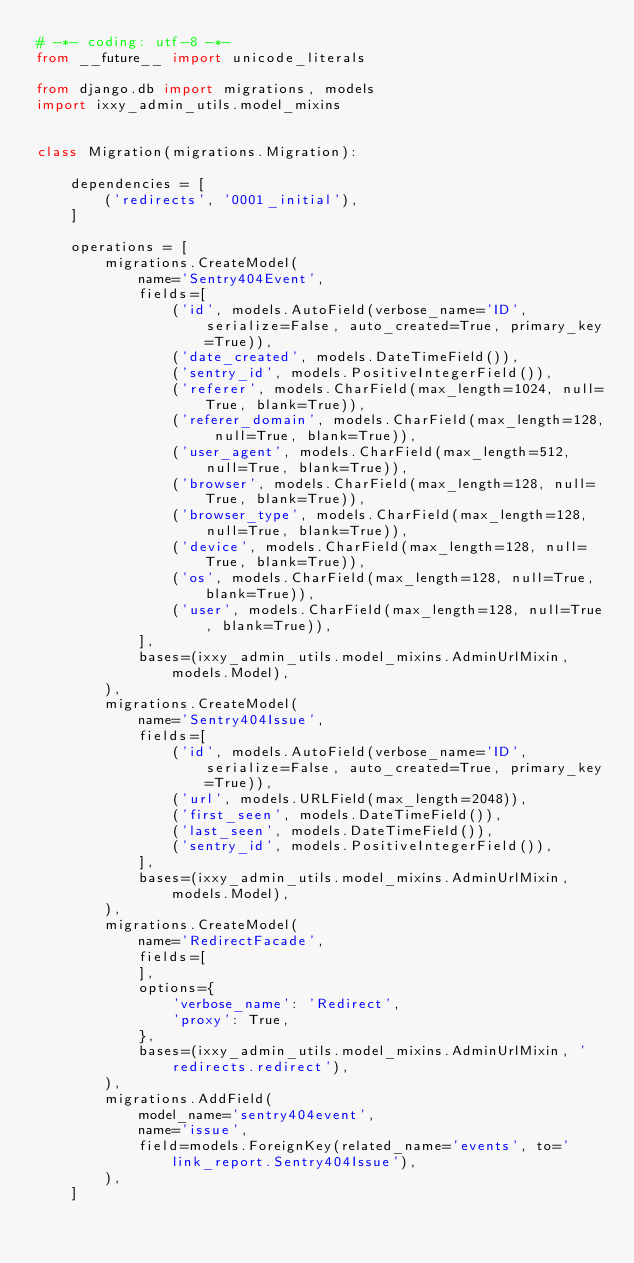<code> <loc_0><loc_0><loc_500><loc_500><_Python_># -*- coding: utf-8 -*-
from __future__ import unicode_literals

from django.db import migrations, models
import ixxy_admin_utils.model_mixins


class Migration(migrations.Migration):

    dependencies = [
        ('redirects', '0001_initial'),
    ]

    operations = [
        migrations.CreateModel(
            name='Sentry404Event',
            fields=[
                ('id', models.AutoField(verbose_name='ID', serialize=False, auto_created=True, primary_key=True)),
                ('date_created', models.DateTimeField()),
                ('sentry_id', models.PositiveIntegerField()),
                ('referer', models.CharField(max_length=1024, null=True, blank=True)),
                ('referer_domain', models.CharField(max_length=128, null=True, blank=True)),
                ('user_agent', models.CharField(max_length=512, null=True, blank=True)),
                ('browser', models.CharField(max_length=128, null=True, blank=True)),
                ('browser_type', models.CharField(max_length=128, null=True, blank=True)),
                ('device', models.CharField(max_length=128, null=True, blank=True)),
                ('os', models.CharField(max_length=128, null=True, blank=True)),
                ('user', models.CharField(max_length=128, null=True, blank=True)),
            ],
            bases=(ixxy_admin_utils.model_mixins.AdminUrlMixin, models.Model),
        ),
        migrations.CreateModel(
            name='Sentry404Issue',
            fields=[
                ('id', models.AutoField(verbose_name='ID', serialize=False, auto_created=True, primary_key=True)),
                ('url', models.URLField(max_length=2048)),
                ('first_seen', models.DateTimeField()),
                ('last_seen', models.DateTimeField()),
                ('sentry_id', models.PositiveIntegerField()),
            ],
            bases=(ixxy_admin_utils.model_mixins.AdminUrlMixin, models.Model),
        ),
        migrations.CreateModel(
            name='RedirectFacade',
            fields=[
            ],
            options={
                'verbose_name': 'Redirect',
                'proxy': True,
            },
            bases=(ixxy_admin_utils.model_mixins.AdminUrlMixin, 'redirects.redirect'),
        ),
        migrations.AddField(
            model_name='sentry404event',
            name='issue',
            field=models.ForeignKey(related_name='events', to='link_report.Sentry404Issue'),
        ),
    ]
</code> 